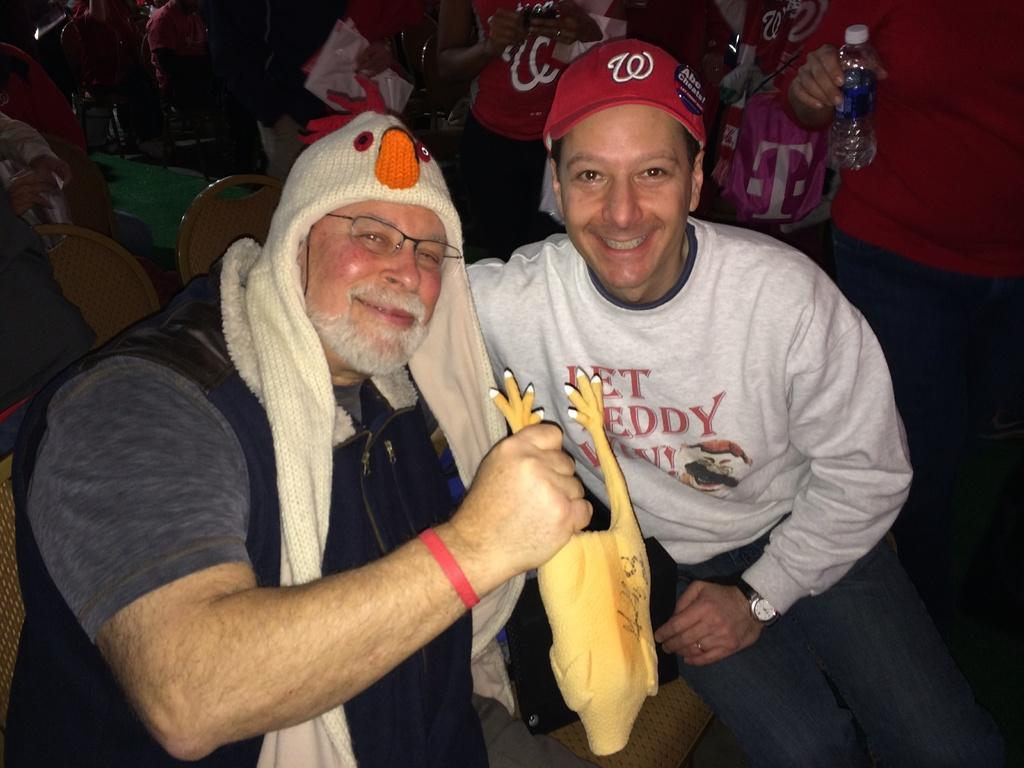<image>
Create a compact narrative representing the image presented. a man holding a rubber chicken is sitting beside a man with a W on his red hat 